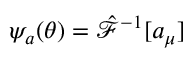<formula> <loc_0><loc_0><loc_500><loc_500>\psi _ { a } ( \theta ) = \hat { \mathcal { F } } ^ { - 1 } [ a _ { \mu } ]</formula> 